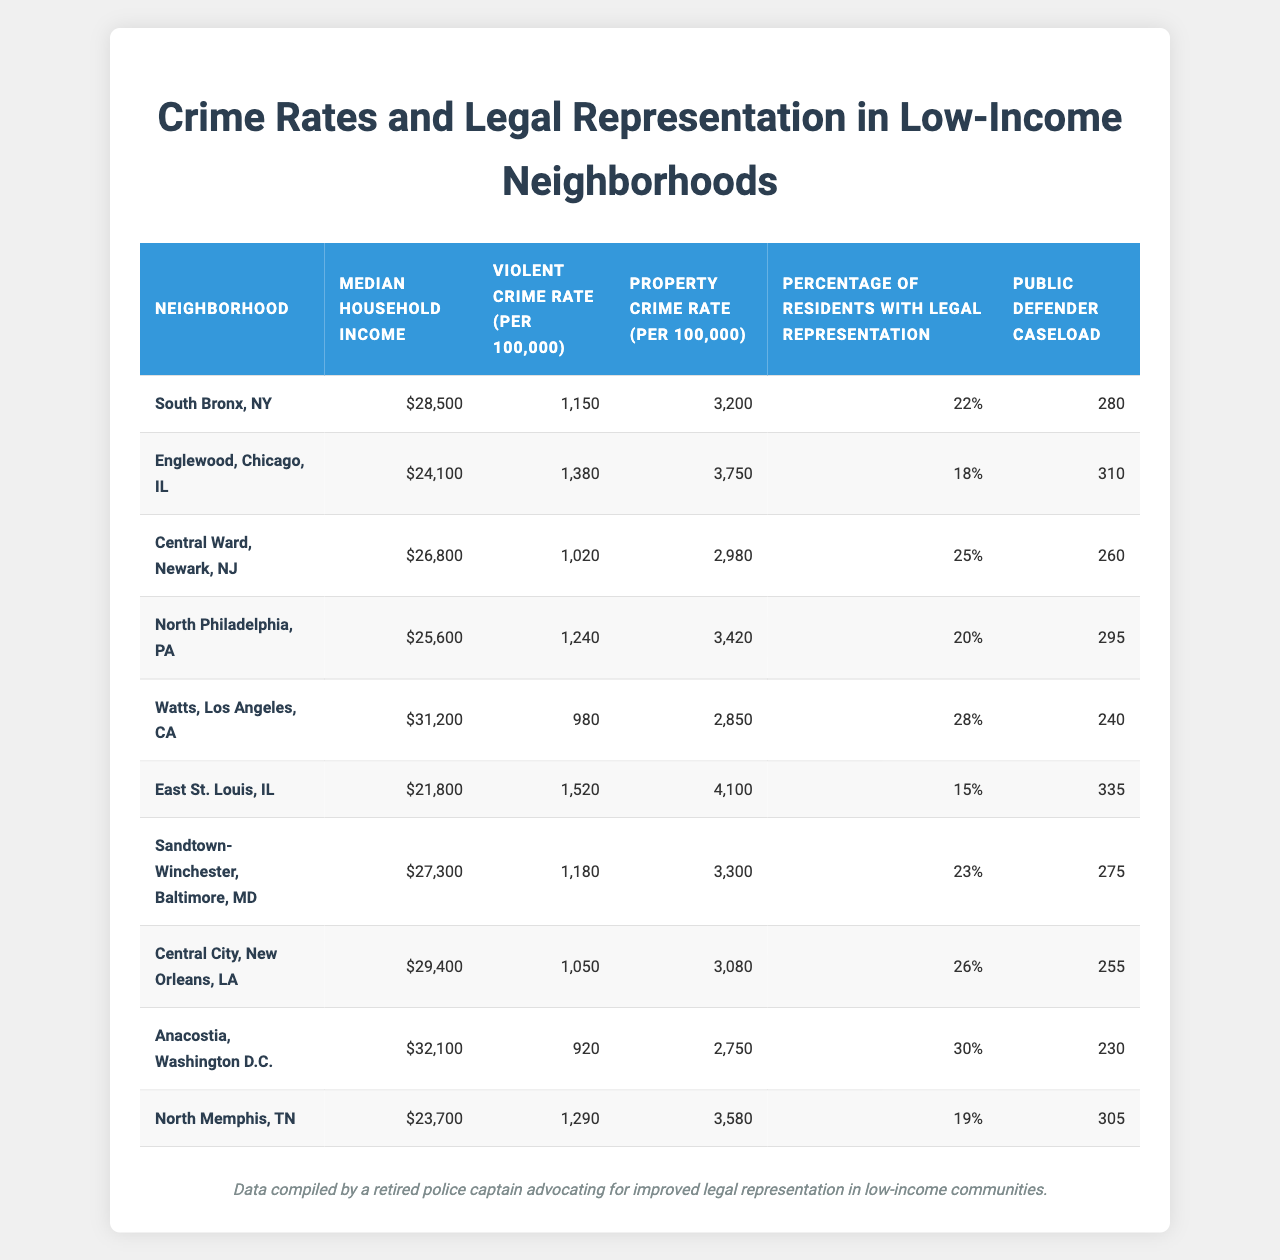What is the median household income for South Bronx, NY? The table shows the median household income for South Bronx, NY is listed in the second column, which states $28,500.
Answer: $28,500 What is the violent crime rate in Englewood, Chicago, IL? The violent crime rate for Englewood, Chicago, IL is found in the third column of the table, specifically listed as 1,380 per 100,000.
Answer: 1,380 Which neighborhood has the highest property crime rate? By reviewing the property crime rates listed, Englewood, Chicago, IL has the highest rate of 3,750 per 100,000.
Answer: Englewood, Chicago, IL Is there a correlation between low household income and high violent crime rates in the table? Generally, neighborhoods with lower median household incomes, such as East St. Louis, IL ($21,800) have higher violent crime rates (1,520). This pattern appears consistently amongst the data, indicating a possible correlation.
Answer: Yes What is the average percentage of residents with legal representation across all neighborhoods in the table? To find the average, add the percentages of residents with legal representation: (22 + 18 + 25 + 20 + 28 + 15 + 23 + 26 + 30 + 19) =  22.5; then divide by 10, which gives 22.5%.
Answer: 22.5% In which neighborhood is the public defender caseload highest? The highest public defender caseload is in East St. Louis, IL, with a caseload of 335. This is found in the last column of the table.
Answer: East St. Louis, IL How much higher is the violent crime rate in North Philadelphia, PA compared to Watts, Los Angeles, CA? The violent crime rate in North Philadelphia is 1,240, while in Watts it is 980. Subtracting gives: 1,240 - 980 = 260.
Answer: 260 Compare the median household income for North Memphis, TN and Central Ward, Newark, NJ. Which one has a higher income? North Memphis, TN has a median income of $23,700, while Central Ward, Newark, NJ has $26,800. Comparing these values reveals that Central Ward has the higher income.
Answer: Central Ward, Newark, NJ What trends can be observed regarding legal representation and violent crime rates among these neighborhoods? Looking at the data, neighborhoods with higher percentages of legal representation, like Anacostia (30%) and Central Ward (25%), tend to have lower violent crime rates (920 and 1,020 respectively). Conversely, regions with lower legal representation, such as East St. Louis (15%), show higher violent crime rates (1,520).
Answer: Higher legal representation coincides with lower violent crime rates What is the total number of legal representation percentages for the neighborhoods listed? To find the total, sum the percentages of residents with legal representation: 22 + 18 + 25 + 20 + 28 + 15 + 23 + 26 + 30 + 19 =  226.
Answer: 226 Which neighborhood shows the least public defender caseload? Anacostia, Washington D.C. has the least public defender caseload at 230, as listed in the last column.
Answer: Anacostia, Washington D.C 